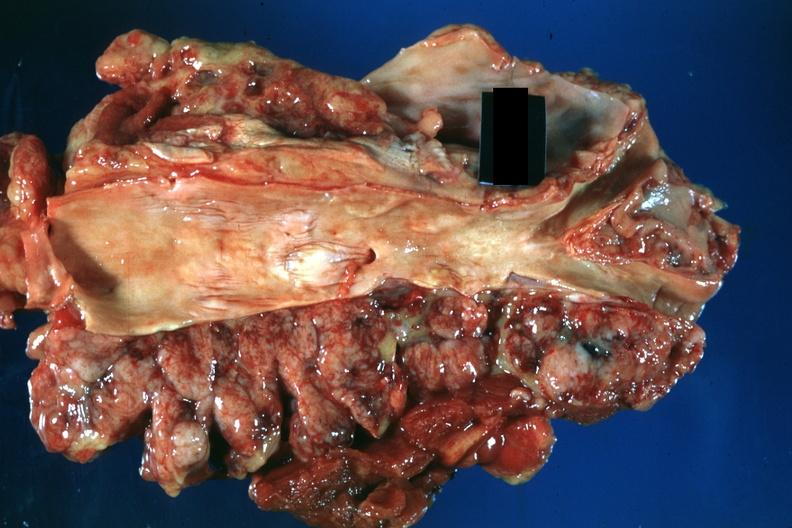what is present?
Answer the question using a single word or phrase. Lymph node 